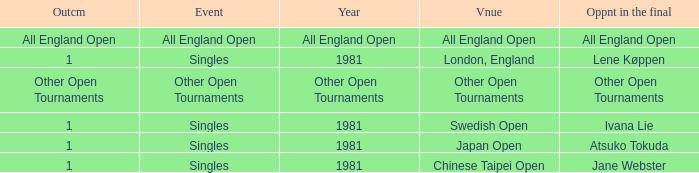What is the Outcome of the Singles Event in London, England? 1.0. 